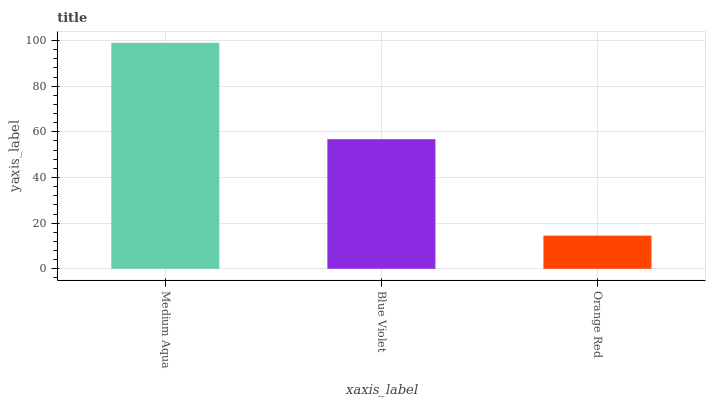Is Orange Red the minimum?
Answer yes or no. Yes. Is Medium Aqua the maximum?
Answer yes or no. Yes. Is Blue Violet the minimum?
Answer yes or no. No. Is Blue Violet the maximum?
Answer yes or no. No. Is Medium Aqua greater than Blue Violet?
Answer yes or no. Yes. Is Blue Violet less than Medium Aqua?
Answer yes or no. Yes. Is Blue Violet greater than Medium Aqua?
Answer yes or no. No. Is Medium Aqua less than Blue Violet?
Answer yes or no. No. Is Blue Violet the high median?
Answer yes or no. Yes. Is Blue Violet the low median?
Answer yes or no. Yes. Is Medium Aqua the high median?
Answer yes or no. No. Is Orange Red the low median?
Answer yes or no. No. 